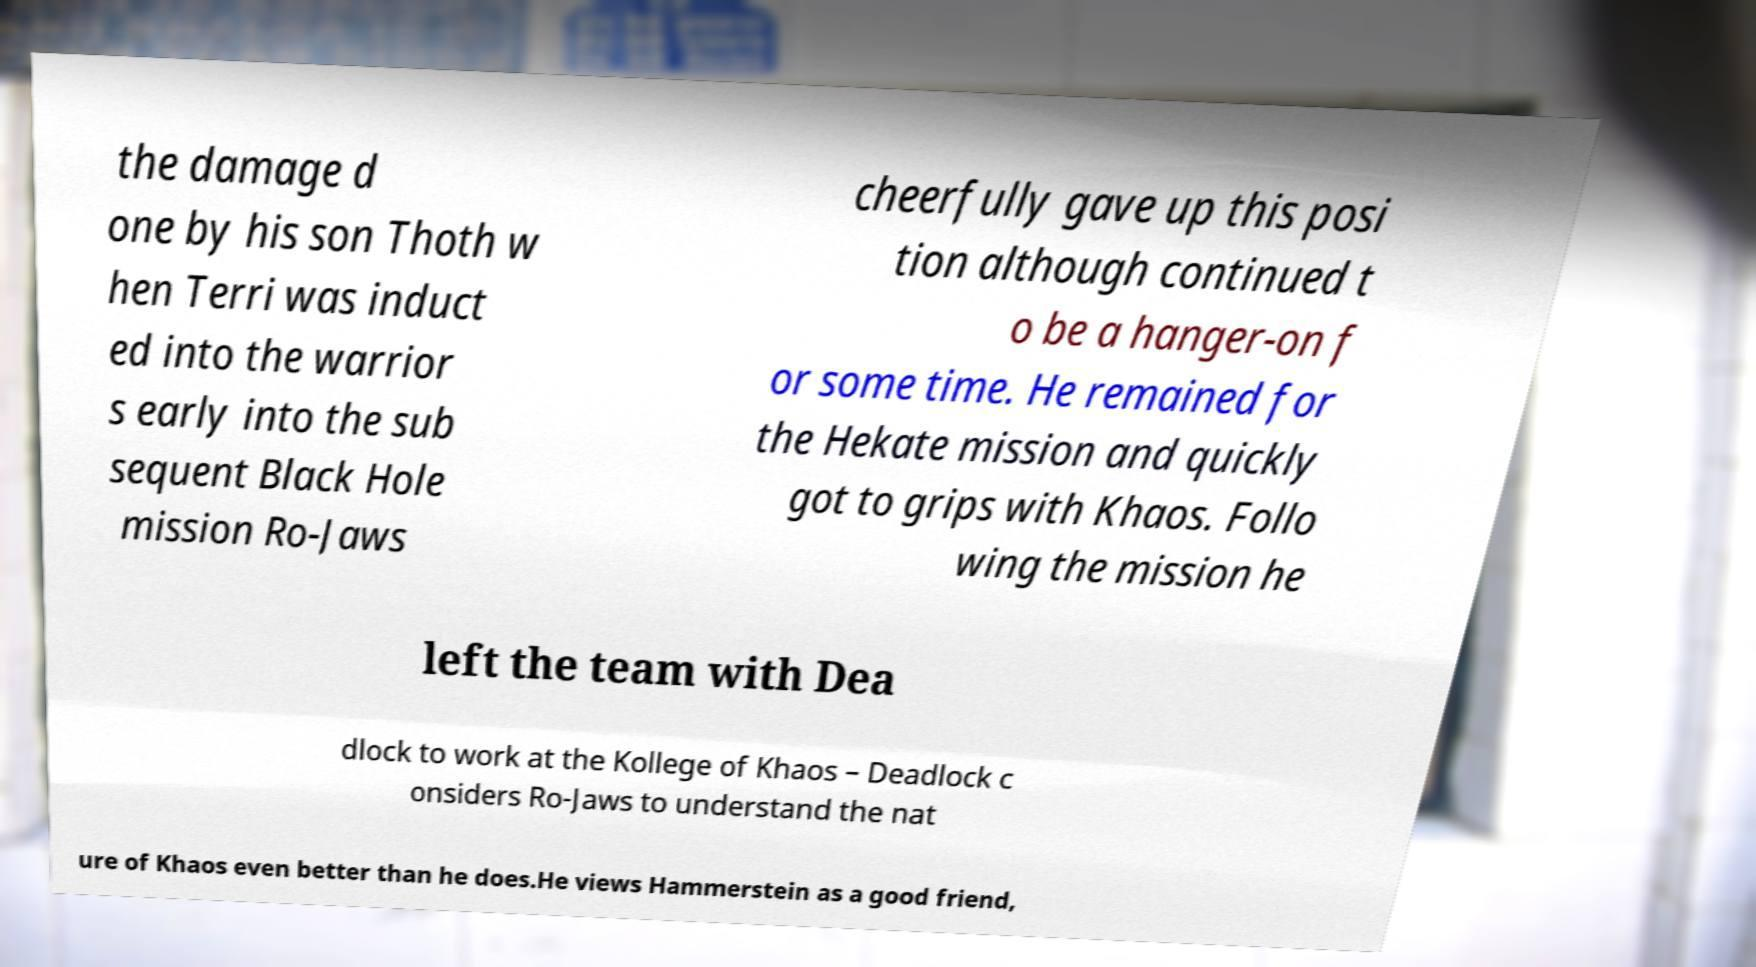There's text embedded in this image that I need extracted. Can you transcribe it verbatim? the damage d one by his son Thoth w hen Terri was induct ed into the warrior s early into the sub sequent Black Hole mission Ro-Jaws cheerfully gave up this posi tion although continued t o be a hanger-on f or some time. He remained for the Hekate mission and quickly got to grips with Khaos. Follo wing the mission he left the team with Dea dlock to work at the Kollege of Khaos – Deadlock c onsiders Ro-Jaws to understand the nat ure of Khaos even better than he does.He views Hammerstein as a good friend, 